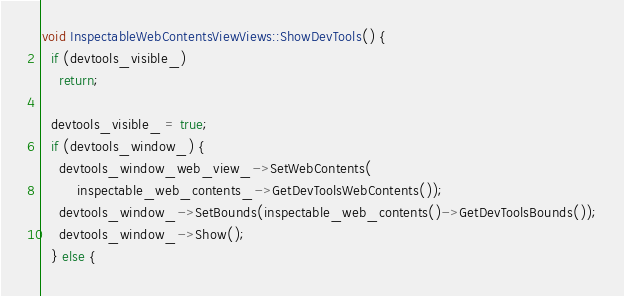<code> <loc_0><loc_0><loc_500><loc_500><_C++_>void InspectableWebContentsViewViews::ShowDevTools() {
  if (devtools_visible_)
    return;

  devtools_visible_ = true;
  if (devtools_window_) {
    devtools_window_web_view_->SetWebContents(
        inspectable_web_contents_->GetDevToolsWebContents());
    devtools_window_->SetBounds(inspectable_web_contents()->GetDevToolsBounds());
    devtools_window_->Show();
  } else {</code> 